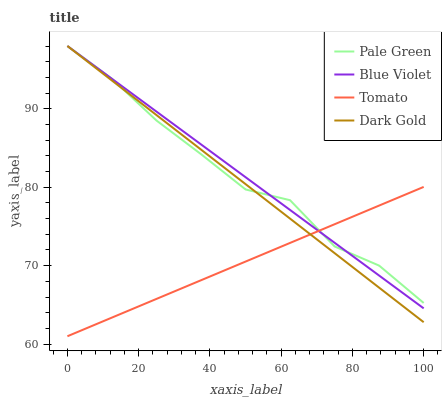Does Tomato have the minimum area under the curve?
Answer yes or no. Yes. Does Blue Violet have the maximum area under the curve?
Answer yes or no. Yes. Does Pale Green have the minimum area under the curve?
Answer yes or no. No. Does Pale Green have the maximum area under the curve?
Answer yes or no. No. Is Tomato the smoothest?
Answer yes or no. Yes. Is Pale Green the roughest?
Answer yes or no. Yes. Is Blue Violet the smoothest?
Answer yes or no. No. Is Blue Violet the roughest?
Answer yes or no. No. Does Tomato have the lowest value?
Answer yes or no. Yes. Does Blue Violet have the lowest value?
Answer yes or no. No. Does Dark Gold have the highest value?
Answer yes or no. Yes. Does Dark Gold intersect Blue Violet?
Answer yes or no. Yes. Is Dark Gold less than Blue Violet?
Answer yes or no. No. Is Dark Gold greater than Blue Violet?
Answer yes or no. No. 